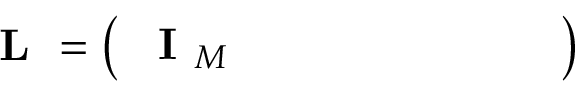<formula> <loc_0><loc_0><loc_500><loc_500>L = \left ( \begin{array} { l l l l l l l l } { I _ { M } } \end{array} \right )</formula> 